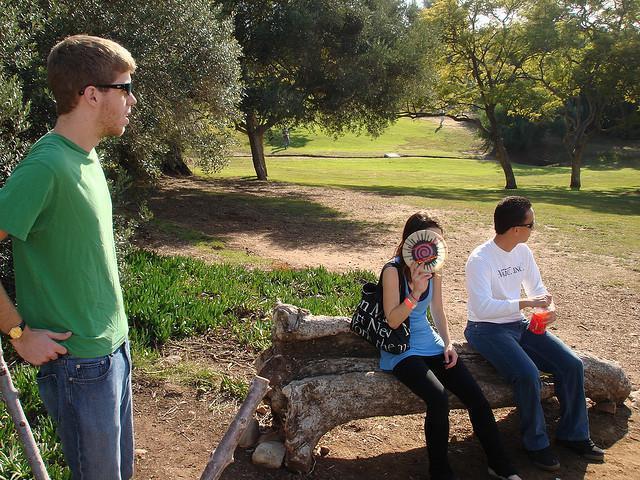How many people are visible?
Give a very brief answer. 3. How many giraffes are sitting there?
Give a very brief answer. 0. 